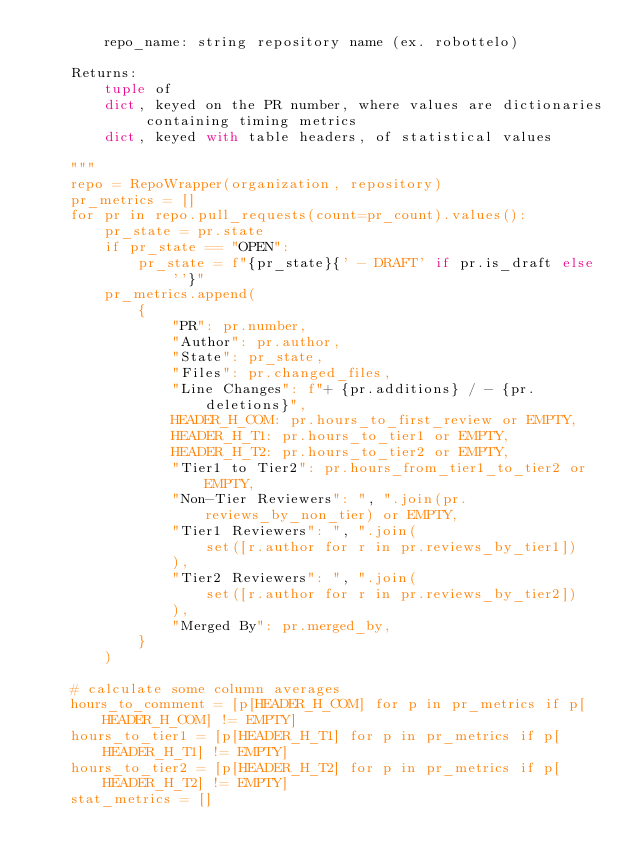Convert code to text. <code><loc_0><loc_0><loc_500><loc_500><_Python_>        repo_name: string repository name (ex. robottelo)

    Returns:
        tuple of
        dict, keyed on the PR number, where values are dictionaries containing timing metrics
        dict, keyed with table headers, of statistical values

    """
    repo = RepoWrapper(organization, repository)
    pr_metrics = []
    for pr in repo.pull_requests(count=pr_count).values():
        pr_state = pr.state
        if pr_state == "OPEN":
            pr_state = f"{pr_state}{' - DRAFT' if pr.is_draft else ''}"
        pr_metrics.append(
            {
                "PR": pr.number,
                "Author": pr.author,
                "State": pr_state,
                "Files": pr.changed_files,
                "Line Changes": f"+ {pr.additions} / - {pr.deletions}",
                HEADER_H_COM: pr.hours_to_first_review or EMPTY,
                HEADER_H_T1: pr.hours_to_tier1 or EMPTY,
                HEADER_H_T2: pr.hours_to_tier2 or EMPTY,
                "Tier1 to Tier2": pr.hours_from_tier1_to_tier2 or EMPTY,
                "Non-Tier Reviewers": ", ".join(pr.reviews_by_non_tier) or EMPTY,
                "Tier1 Reviewers": ", ".join(
                    set([r.author for r in pr.reviews_by_tier1])
                ),
                "Tier2 Reviewers": ", ".join(
                    set([r.author for r in pr.reviews_by_tier2])
                ),
                "Merged By": pr.merged_by,
            }
        )

    # calculate some column averages
    hours_to_comment = [p[HEADER_H_COM] for p in pr_metrics if p[HEADER_H_COM] != EMPTY]
    hours_to_tier1 = [p[HEADER_H_T1] for p in pr_metrics if p[HEADER_H_T1] != EMPTY]
    hours_to_tier2 = [p[HEADER_H_T2] for p in pr_metrics if p[HEADER_H_T2] != EMPTY]
    stat_metrics = []</code> 